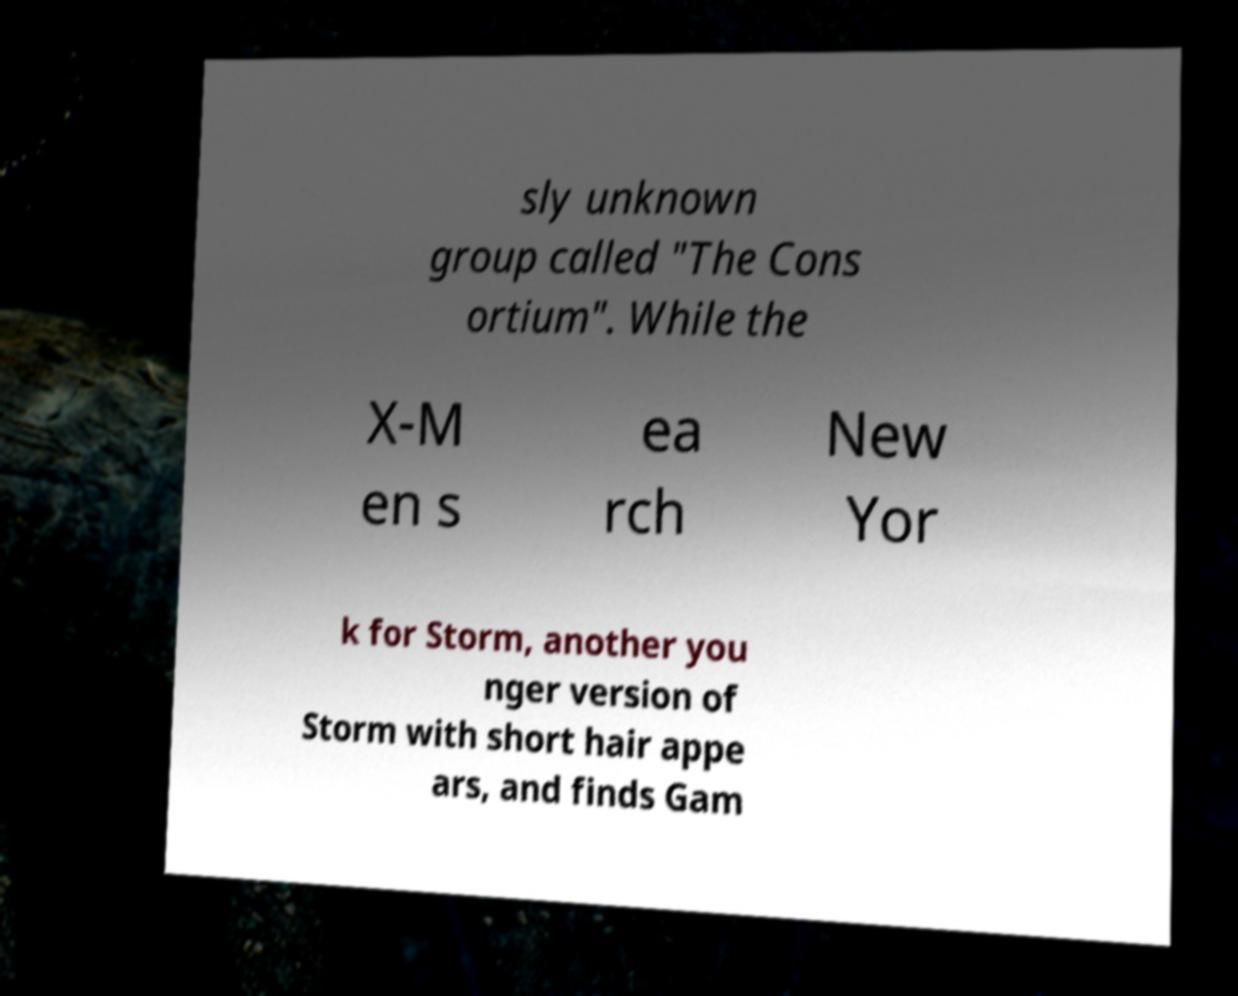Can you accurately transcribe the text from the provided image for me? sly unknown group called "The Cons ortium". While the X-M en s ea rch New Yor k for Storm, another you nger version of Storm with short hair appe ars, and finds Gam 